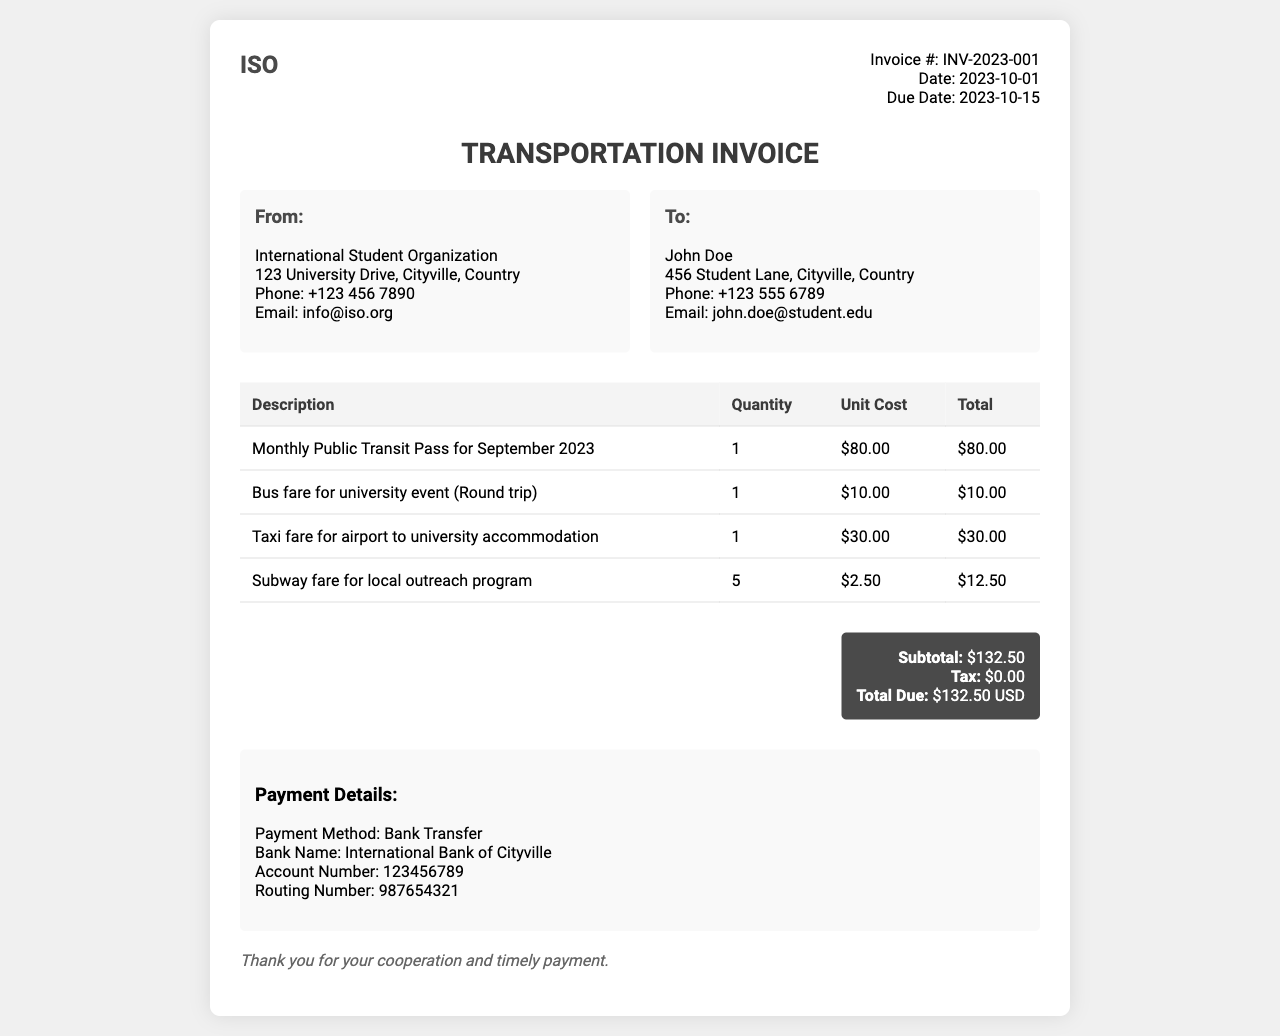What is the invoice number? The invoice number is specified in the document as "INV-2023-001."
Answer: INV-2023-001 What is the due date of the invoice? The due date is clearly stated in the document as "2023-10-15."
Answer: 2023-10-15 Who is the recipient of the invoice? The recipient's name is mentioned in the document as "John Doe."
Answer: John Doe What is the total amount due? The total amount due at the bottom of the invoice is "$132.50 USD."
Answer: $132.50 USD How much does the monthly public transit pass cost? The cost for the monthly public transit pass is listed as "$80.00."
Answer: $80.00 How many subway fares were included in the invoice? The invoice details that "5" subway fares were charged for the outreach program.
Answer: 5 What payment method is specified in the invoice? The payment method described in the document is "Bank Transfer."
Answer: Bank Transfer What was the total cost for the taxi fare? The total cost for the taxi fare is "$30.00."
Answer: $30.00 What is the subtotal before tax? The subtotal before tax on the invoice is "$132.50."
Answer: $132.50 